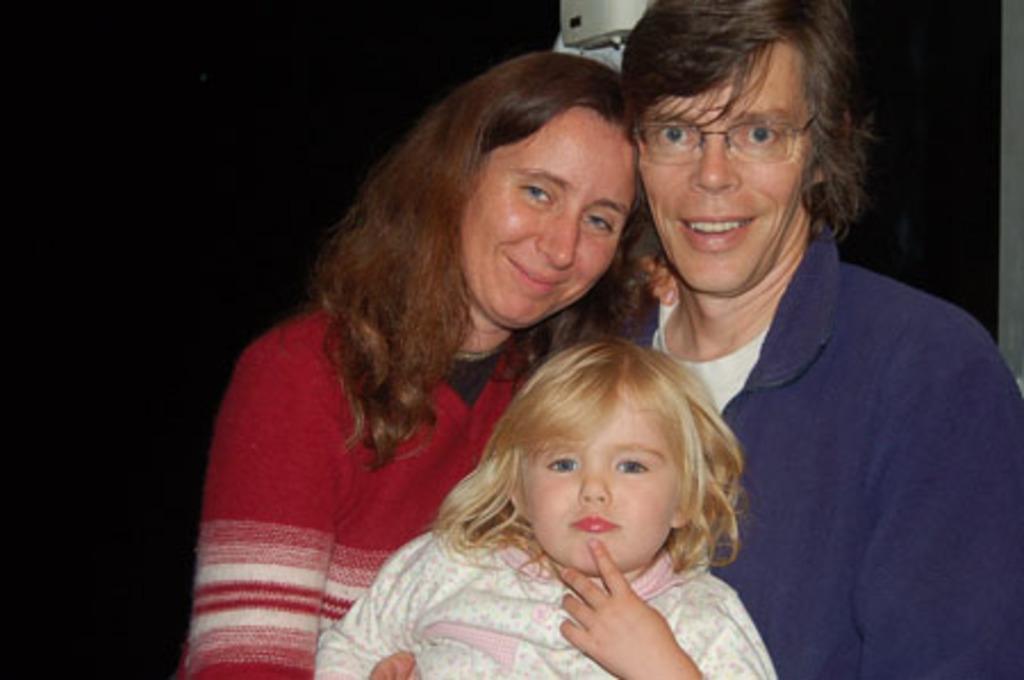Please provide a concise description of this image. In this image there is a woman. Beside there is a person wearing spectacles. Bottom of the image there is a girl. Top of the image there is an object. Background is in black color. 